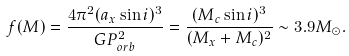<formula> <loc_0><loc_0><loc_500><loc_500>f ( M ) = \frac { 4 \pi ^ { 2 } ( a _ { x } \sin i ) ^ { 3 } } { G P ^ { 2 } _ { o r b } } = \frac { ( M _ { c } \sin i ) ^ { 3 } } { ( M _ { x } + M _ { c } ) ^ { 2 } } \sim 3 . 9 M _ { \odot } .</formula> 